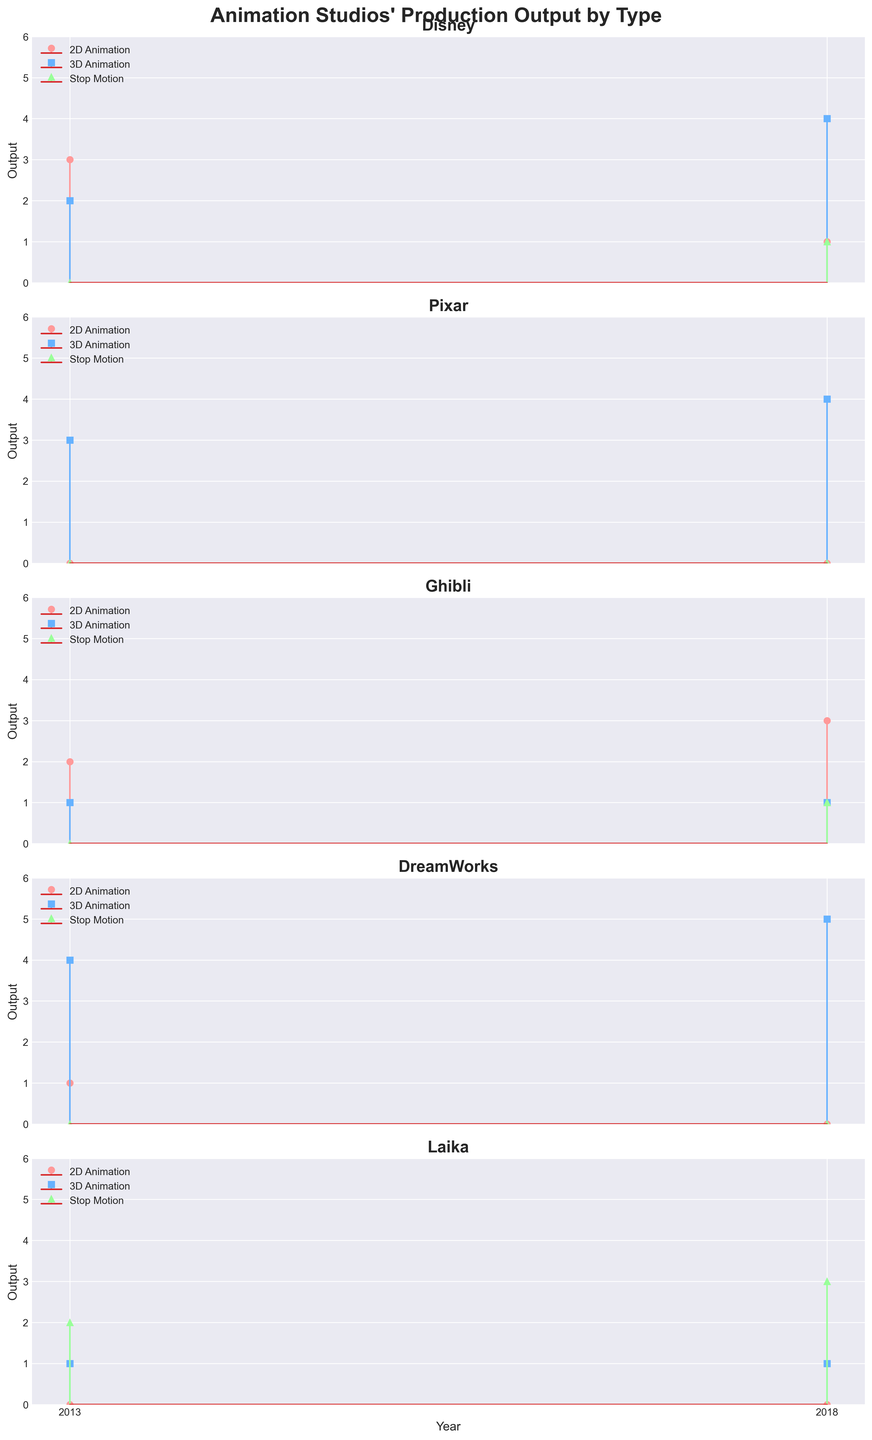what is the title of the plot? The title of the plot is given at the top and is "Animation Studios' Production Output by Type".
Answer: Animation Studios' Production Output by Type How many types of animations does the figure represent? The figure uses three different markers (circle, square, and triangle) to represent three types of animations.
Answer: 3 What color represents 2D Animation in the graph? The colors can be identified in the legend, where 2D Animation is represented by a pinkish color.
Answer: Pink Which studio had the highest output for 3D Animation in 2018? By examining the 2018 data points from each subplot, DreamWorks has the highest output with a value of 5.
Answer: DreamWorks How many 2D Animations did Disney produce in total from 2013 to 2018? Add the 2D Animation outputs for Disney in 2013 and 2018 (3 + 1). The total is 4.
Answer: 4 Compare the 3D Animation outputs of Pixar and Ghibli in 2013. Which one is higher? In 2013, Pixar produced 3 3D Animations, while Ghibli produced 1. Therefore, Pixar's output is higher.
Answer: Pixar What's the sum output of Stop Motion animations produced by Laika from 2013 to 2018? Add the Stop Motion outputs for Laika in 2013 and 2018 (2 + 3). The total is 5.
Answer: 5 In the 2018 data, which studio didn't produce any 2D Animation? In the 2018 subplots, Pixar and DreamWorks show 0 output for 2D Animation.
Answer: Pixar and DreamWorks Which type of animation saw the highest production increase for DreamWorks from 2013 to 2018? By comparing the different types from 2013 to 2018, 3D Animation for DreamWorks increased from 4 to 5.
Answer: 3D Animation 